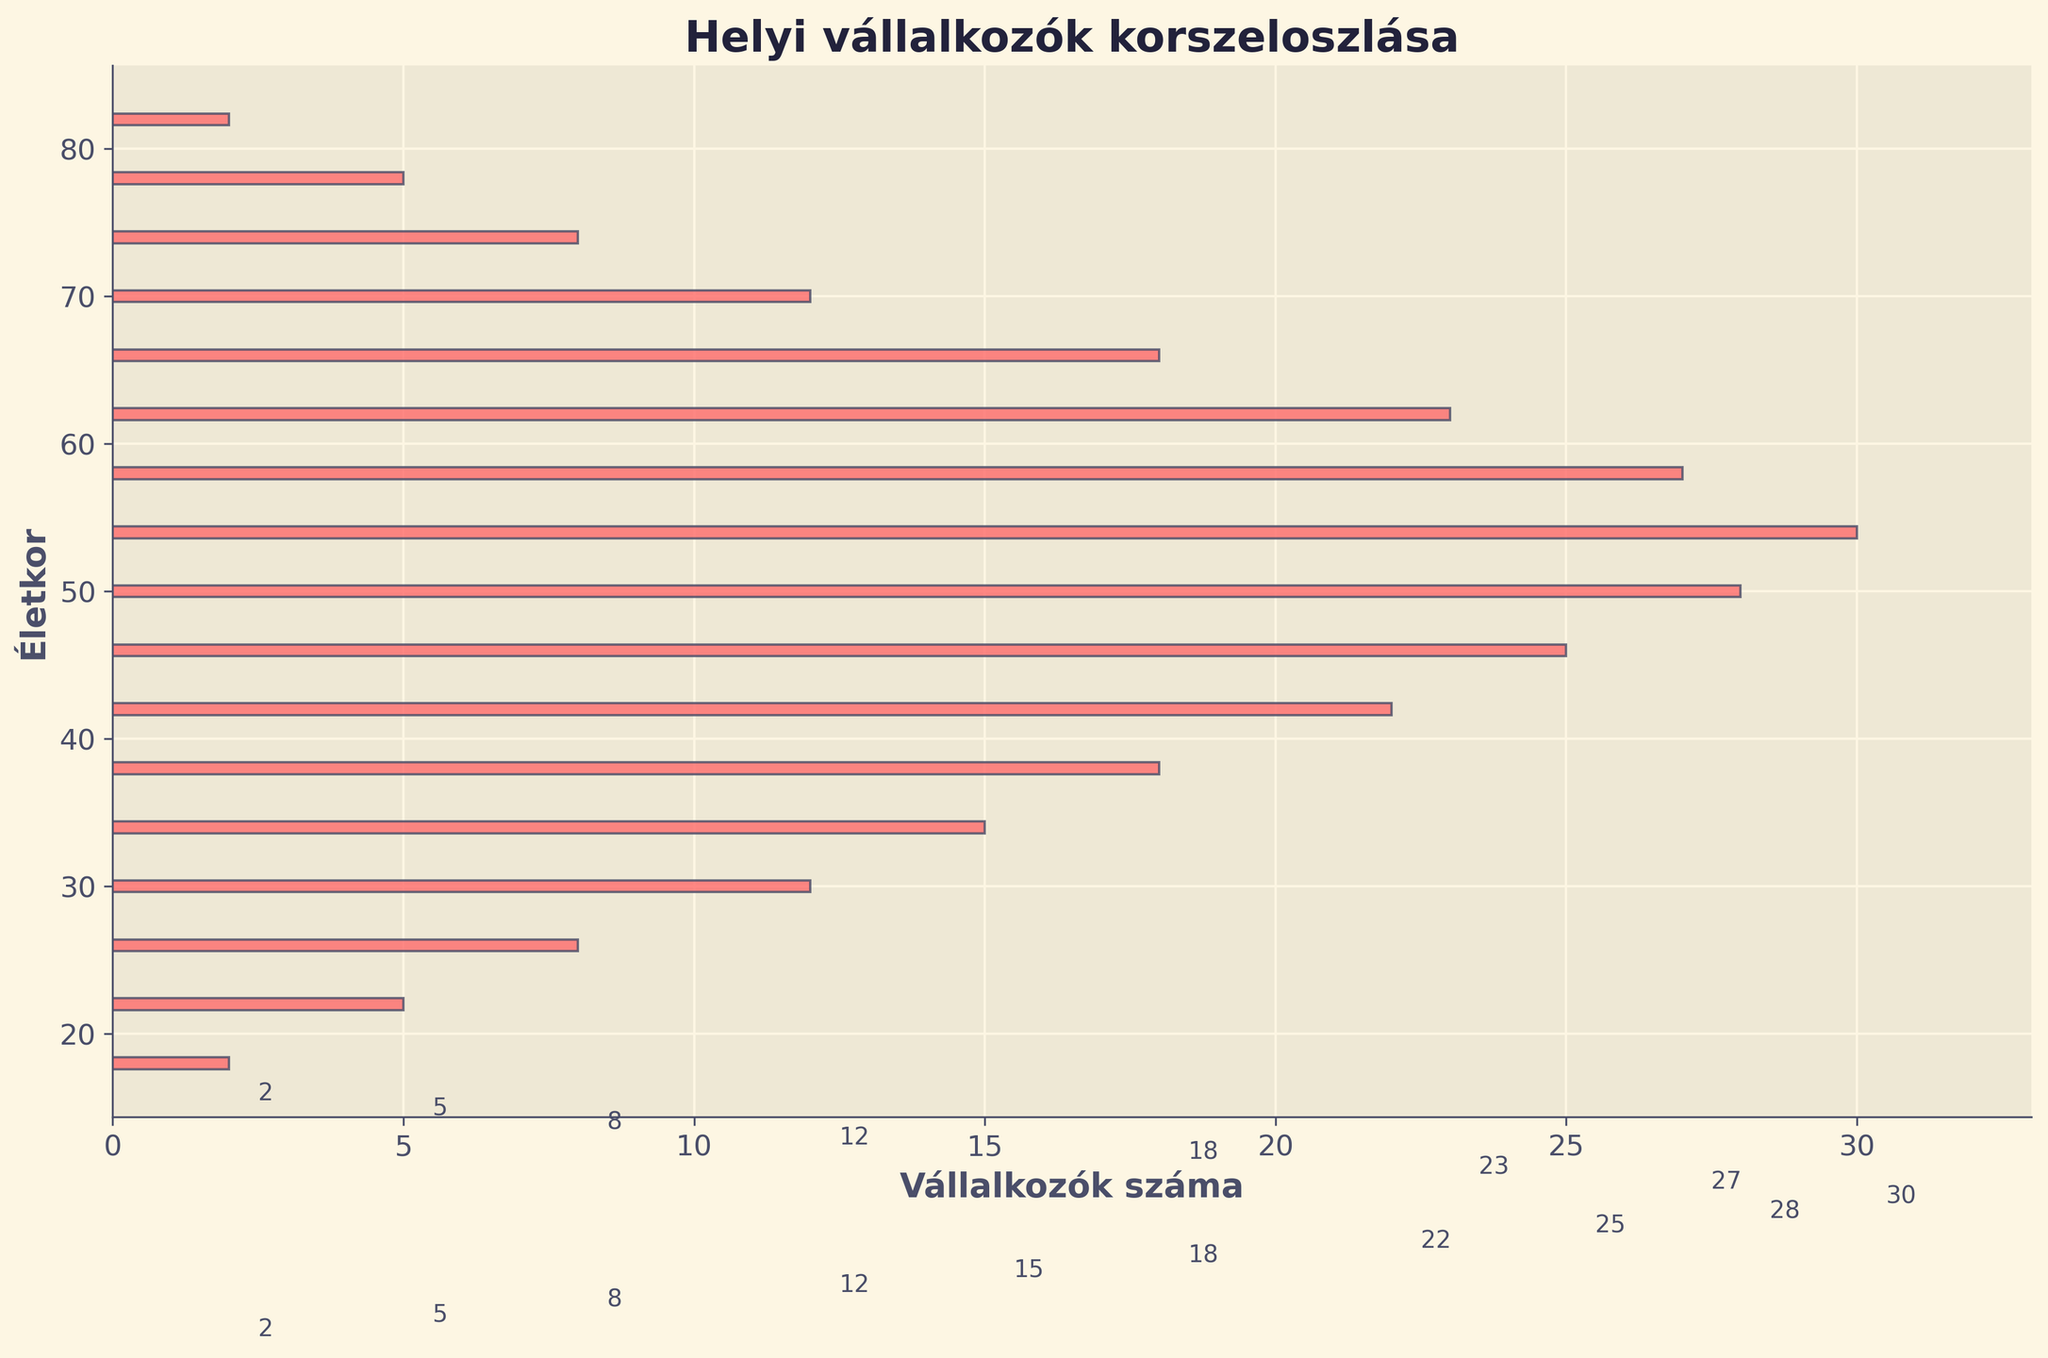what is the title of the figure? The title is prominently displayed at the top of the figure and is relatively large and bold. It reads 'Helyi vállalkozók korszeloszlása'.
Answer: Helyi vállalkozók korszeloszlása How many different age groups are present in the plot? Count the number of different age values listed on the vertical axis. There are 18 different age groups visible in the plot.
Answer: 18 Which age group has the highest number of business owners? Look at the bar that extends the farthest to the right for the highest frequency. The longest bar is at age 54.
Answer: 54 Which age group has the lowest number of business owners? Look for the shortest bars, which are at ages 18 and 82. Both have the same frequency as they are the shortest.
Answer: 18 and 82 What is the total number of business owners above the age of 70? Sum the frequencies for ages above 70: 8 (74) + 5 (78) + 2 (82) = 15.
Answer: 15 What is the average number of business owners for the age groups 30, 34, and 38? Add the frequencies for these ages and divide by the number of groups: (12 + 15 + 18) / 3 = 15.
Answer: 15 Which age group between 40 and 50 has more business owners? Compare the frequencies for ages 42, 46, and 50. Age 50 has the highest frequency with 28 business owners.
Answer: 50 How many more business owners are there at age 50 compared to age 30? Subtract the frequency at age 30 from that at age 50: 28 - 12 = 16.
Answer: 16 What trend is noticeable in the age distribution of business owners? The general trend shows that the number of business owners increases with age, peaks around 54, and then decreases, indicating higher entrepreneurship in middle age.
Answer: Peaks at middle age, then decreases How does the density of business owners change from age 18 to age 54? Observe the increasing trend in bar lengths from age 18 to age 54, indicating a significant rise in the number of business owners as age increases.
Answer: Increases significantly 